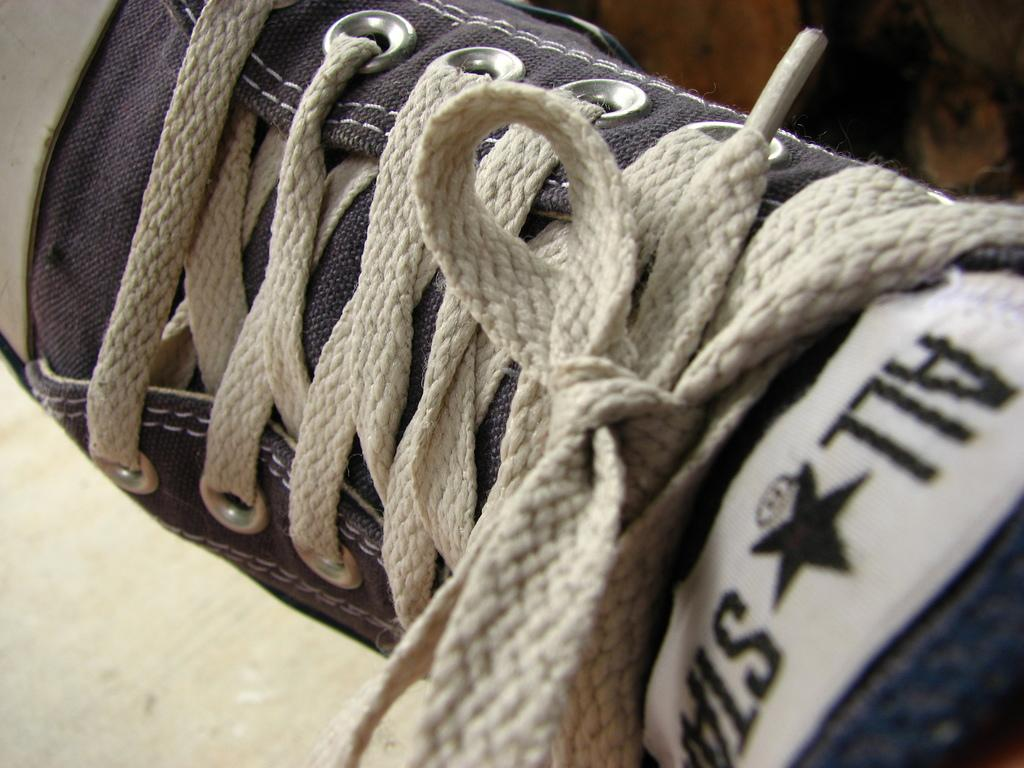What object is present in the image? There is a shoe in the image. How are the shoelaces on the shoe? The shoelaces are tied on the shoe. What can be found on the shoe besides the shoelaces? There is text and a star symbol on the shoe. Where is the lunchroom located in the image? There is no lunchroom present in the image. 